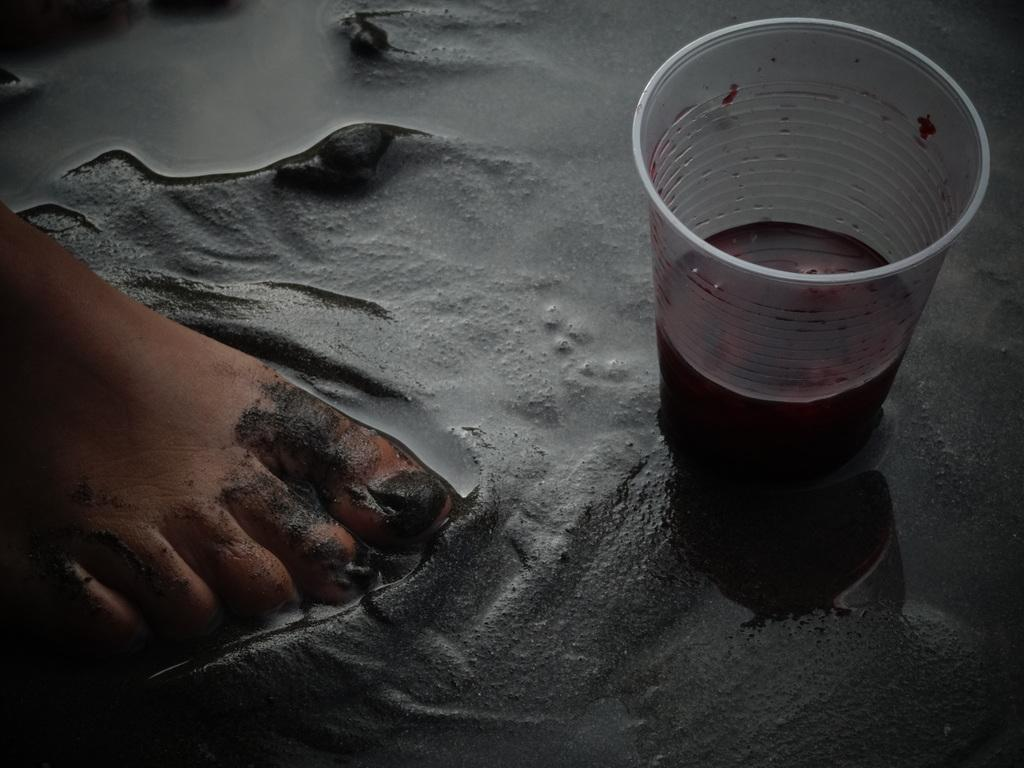What part of a person's body is visible on the cement in the image? There is a person's leg on the cement in the image. What natural element is present in the image? There is water visible in the image. What type of container is holding a drink in the image? There is a cup with a drink in the image. What type of mint is growing on the wall in the image? There is no wall or mint present in the image. How does the person wash their leg in the image? There is no indication of the person washing their leg in the image. 